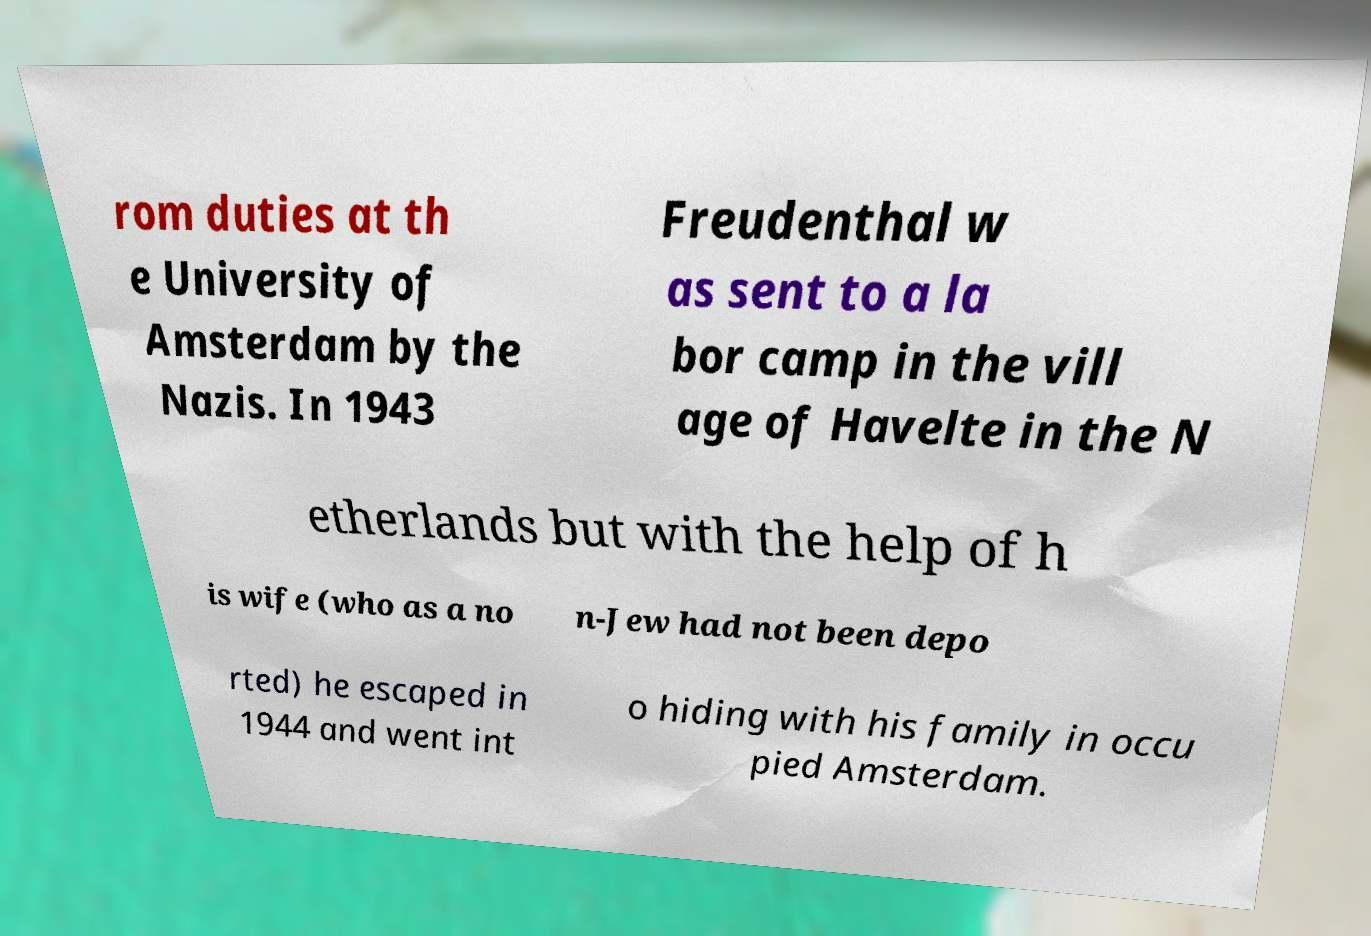I need the written content from this picture converted into text. Can you do that? rom duties at th e University of Amsterdam by the Nazis. In 1943 Freudenthal w as sent to a la bor camp in the vill age of Havelte in the N etherlands but with the help of h is wife (who as a no n-Jew had not been depo rted) he escaped in 1944 and went int o hiding with his family in occu pied Amsterdam. 